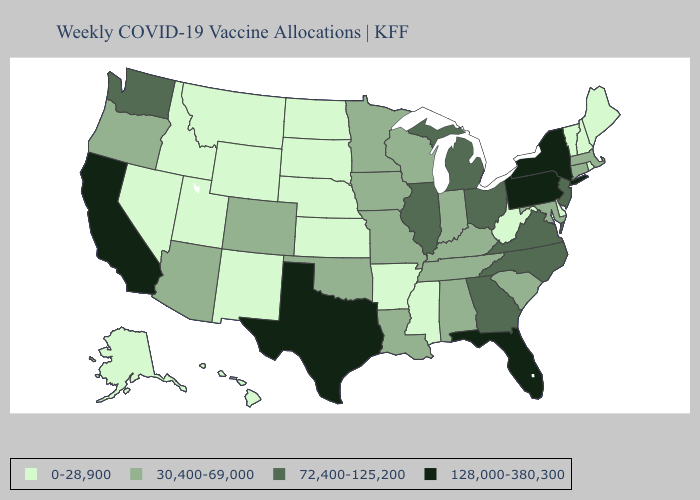Among the states that border Montana , which have the lowest value?
Give a very brief answer. Idaho, North Dakota, South Dakota, Wyoming. What is the lowest value in states that border Montana?
Short answer required. 0-28,900. Does Delaware have the same value as Louisiana?
Be succinct. No. What is the value of New Hampshire?
Concise answer only. 0-28,900. Does Texas have the highest value in the USA?
Answer briefly. Yes. What is the lowest value in the West?
Give a very brief answer. 0-28,900. What is the lowest value in the Northeast?
Keep it brief. 0-28,900. What is the value of South Carolina?
Quick response, please. 30,400-69,000. Does South Carolina have the lowest value in the USA?
Answer briefly. No. Name the states that have a value in the range 72,400-125,200?
Write a very short answer. Georgia, Illinois, Michigan, New Jersey, North Carolina, Ohio, Virginia, Washington. What is the lowest value in the USA?
Quick response, please. 0-28,900. Does Missouri have a lower value than Alaska?
Short answer required. No. How many symbols are there in the legend?
Answer briefly. 4. What is the value of Arizona?
Quick response, please. 30,400-69,000. Name the states that have a value in the range 72,400-125,200?
Answer briefly. Georgia, Illinois, Michigan, New Jersey, North Carolina, Ohio, Virginia, Washington. 